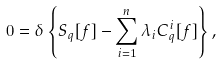<formula> <loc_0><loc_0><loc_500><loc_500>0 = \delta \left \{ S _ { q } [ f ] - \sum _ { i = 1 } ^ { n } \lambda _ { i } C ^ { i } _ { q } [ f ] \right \} ,</formula> 